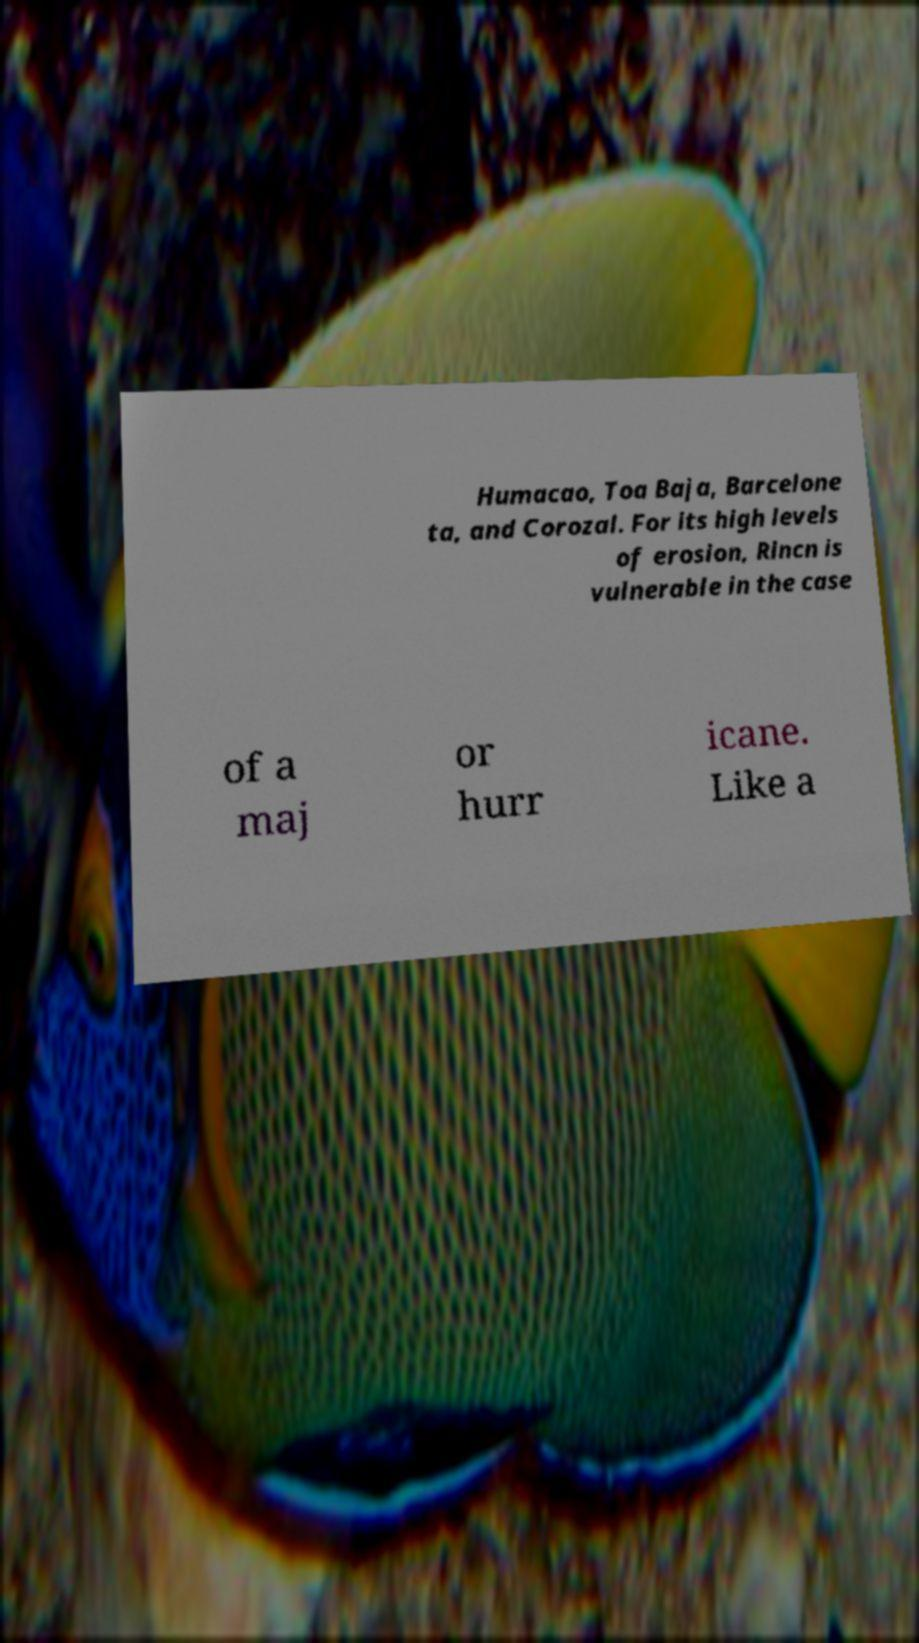Could you extract and type out the text from this image? Humacao, Toa Baja, Barcelone ta, and Corozal. For its high levels of erosion, Rincn is vulnerable in the case of a maj or hurr icane. Like a 